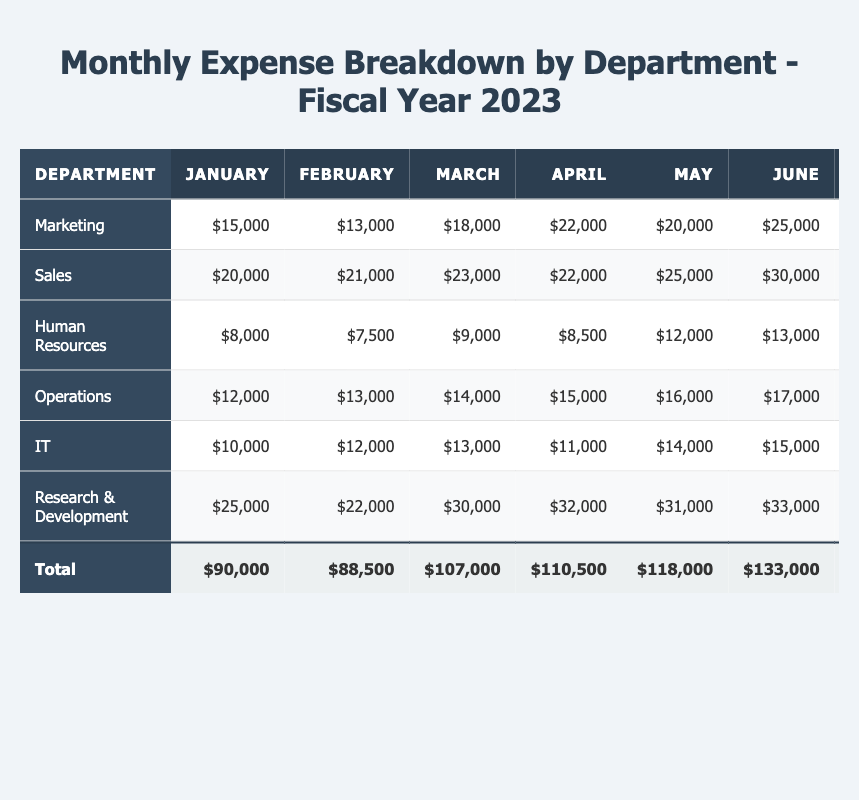What was the total expense for the Marketing department in 2023? To find the total expense for the Marketing department, we add all the monthly expenses: 15000 + 13000 + 18000 + 22000 + 20000 + 25000 + 24000 + 26000 + 29000 + 30000 + 31000 + 32000 = 285000
Answer: 285000 Which department had the highest monthly expense in December 2023? To find the highest expense in December, we look at the December values for all departments: Marketing (32000), Sales (25000), Human Resources (15000), Operations (23000), IT (21000), Research & Development (40000). The highest is 40000 from Research & Development.
Answer: Research & Development What were the total expenses for the Human Resources department from January to June? We sum the expenses from January to June: 8000 + 7500 + 9000 + 8500 + 12000 + 13000 = 51500
Answer: 51500 Did the IT department spend more than the Operations department in total for the fiscal year? Total for IT is 186000 and Operations is 210000. Since 186000 is less than 210000, the IT department did not spend more.
Answer: No What is the average monthly expense for the Sales department in 2023? The total for Sales is 316000. There are 12 months, so the average is 316000 ÷ 12 = 26333.33.
Answer: 26333.33 Which department showed a consistent increase in expenses month-over-month? By examining the table for each department, we note that Research & Development shows an increase every month from January to December without any decreases.
Answer: Research & Development What was the percentage increase in expenses for the Marketing department from January to December? The expense in January is 15000, and in December it is 32000. The increase is 32000 - 15000 = 17000. The percentage increase is (17000 / 15000) × 100 = 113.33%.
Answer: 113.33% Calculate the total expenses across all departments for the first quarter (Q1) of 2023. For Q1, we add up the expenses for January, February, and March across all departments: (15000 + 20000 + 8000 + 12000 + 10000 + 25000) + (13000 + 21000 + 7500 + 13000 + 12000 + 22000) + (18000 + 23000 + 9000 + 14000 + 13000 + 30000) = 208500.
Answer: 208500 What was the total monthly expense for all departments in November compared to the total in October? Total expenses in November: 31000 + 26000 + 14500 + 22000 + 20000 + 39000 = 152500. Total in October: 30000 + 28000 + 13000 + 21000 + 19000 + 38000 = 149000. November's total is greater than October's total.
Answer: Yes Which department had a total expense closest to 300000 for the entire fiscal year? To find this, we compare the total expenses for each department: Marketing (285000), Sales (316000), Human Resources (131000), Operations (210000), IT (186000), Research & Development (397000). Marketing’s total is closest to 300000.
Answer: Marketing 